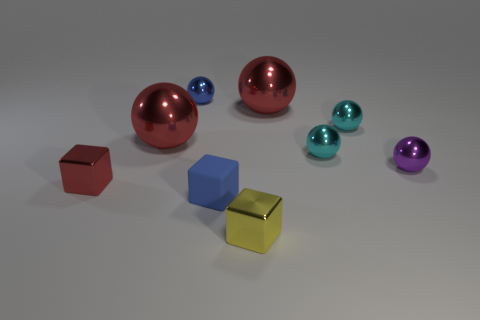What is the material of the thing that is the same color as the rubber cube?
Keep it short and to the point. Metal. Is there another matte thing of the same color as the rubber thing?
Provide a succinct answer. No. What is the shape of the blue thing that is the same size as the blue shiny sphere?
Your answer should be compact. Cube. How many tiny blocks are on the left side of the small metallic block that is right of the red cube?
Your answer should be very brief. 2. How many other things are made of the same material as the small red thing?
Make the answer very short. 7. What shape is the big object that is left of the cube right of the matte thing?
Your answer should be compact. Sphere. There is a metal thing in front of the red block; what size is it?
Your answer should be very brief. Small. Is the material of the red cube the same as the small yellow cube?
Offer a very short reply. Yes. What shape is the yellow object that is made of the same material as the purple object?
Make the answer very short. Cube. Is there anything else that is the same color as the rubber object?
Your response must be concise. Yes. 